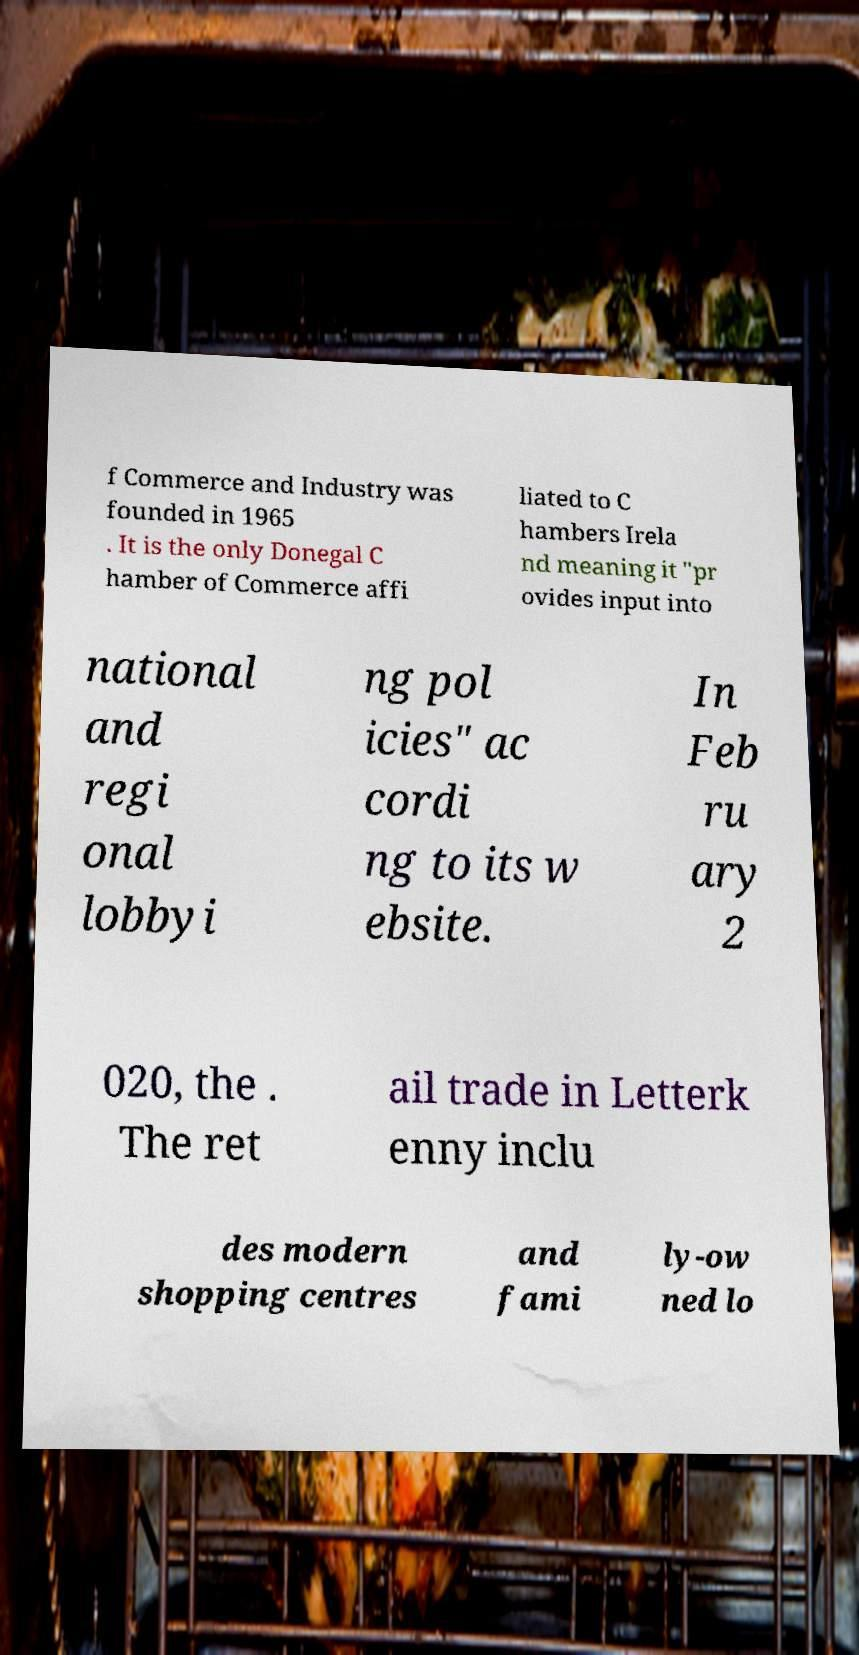There's text embedded in this image that I need extracted. Can you transcribe it verbatim? f Commerce and Industry was founded in 1965 . It is the only Donegal C hamber of Commerce affi liated to C hambers Irela nd meaning it "pr ovides input into national and regi onal lobbyi ng pol icies" ac cordi ng to its w ebsite. In Feb ru ary 2 020, the . The ret ail trade in Letterk enny inclu des modern shopping centres and fami ly-ow ned lo 